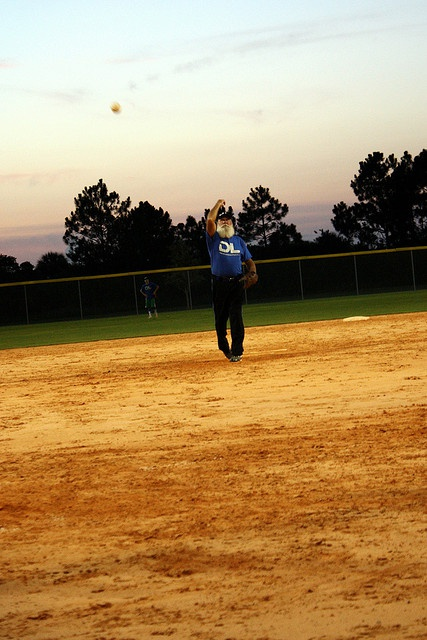Describe the objects in this image and their specific colors. I can see people in lightblue, black, navy, maroon, and olive tones, people in lightblue, black, darkgreen, and gray tones, baseball glove in black, maroon, and lightblue tones, and sports ball in lightblue, khaki, tan, and beige tones in this image. 